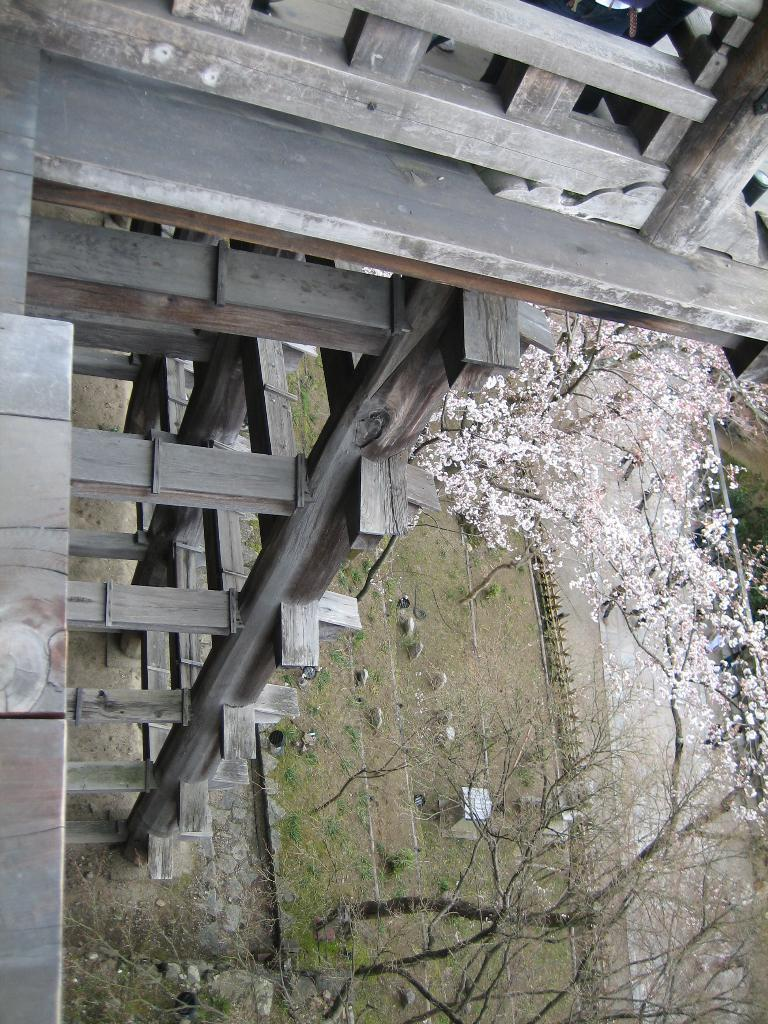What type of structure is visible in the image? There is a wooden structure in the image. What can be seen on the right side of the image? There is a road, trees, fencing, plants, and grass on the right side of the image. Can you describe the vegetation present on the right side of the image? There are trees, plants, and grass on the right side of the image. What type of oil can be seen dripping from the wooden structure in the image? There is no oil present in the image, and the wooden structure does not appear to be dripping anything. Can you tell me how many combs are visible in the image? There are no combs present in the image. 